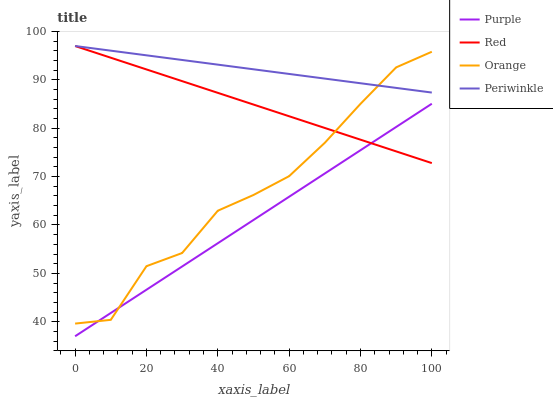Does Purple have the minimum area under the curve?
Answer yes or no. Yes. Does Periwinkle have the maximum area under the curve?
Answer yes or no. Yes. Does Orange have the minimum area under the curve?
Answer yes or no. No. Does Orange have the maximum area under the curve?
Answer yes or no. No. Is Red the smoothest?
Answer yes or no. Yes. Is Orange the roughest?
Answer yes or no. Yes. Is Periwinkle the smoothest?
Answer yes or no. No. Is Periwinkle the roughest?
Answer yes or no. No. Does Purple have the lowest value?
Answer yes or no. Yes. Does Orange have the lowest value?
Answer yes or no. No. Does Red have the highest value?
Answer yes or no. Yes. Does Orange have the highest value?
Answer yes or no. No. Is Purple less than Periwinkle?
Answer yes or no. Yes. Is Periwinkle greater than Purple?
Answer yes or no. Yes. Does Periwinkle intersect Orange?
Answer yes or no. Yes. Is Periwinkle less than Orange?
Answer yes or no. No. Is Periwinkle greater than Orange?
Answer yes or no. No. Does Purple intersect Periwinkle?
Answer yes or no. No. 